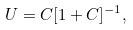<formula> <loc_0><loc_0><loc_500><loc_500>U = C [ 1 + C ] ^ { - 1 } ,</formula> 